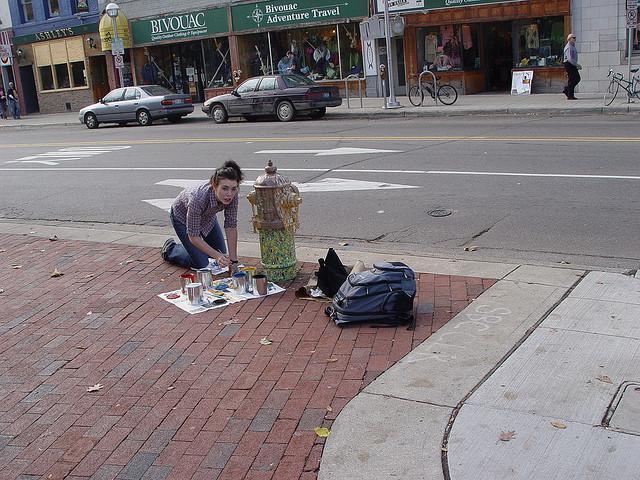How many bicycles are there?
Give a very brief answer. 2. How many cars are there?
Give a very brief answer. 2. 